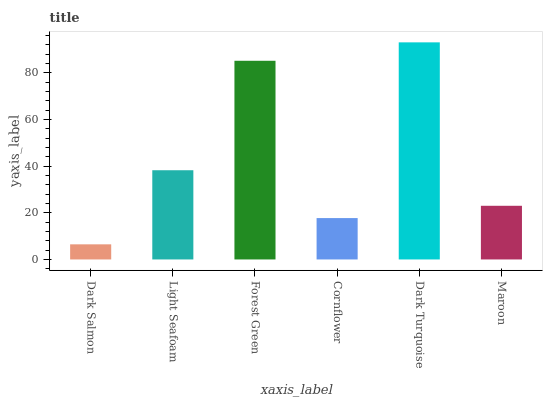Is Dark Salmon the minimum?
Answer yes or no. Yes. Is Dark Turquoise the maximum?
Answer yes or no. Yes. Is Light Seafoam the minimum?
Answer yes or no. No. Is Light Seafoam the maximum?
Answer yes or no. No. Is Light Seafoam greater than Dark Salmon?
Answer yes or no. Yes. Is Dark Salmon less than Light Seafoam?
Answer yes or no. Yes. Is Dark Salmon greater than Light Seafoam?
Answer yes or no. No. Is Light Seafoam less than Dark Salmon?
Answer yes or no. No. Is Light Seafoam the high median?
Answer yes or no. Yes. Is Maroon the low median?
Answer yes or no. Yes. Is Dark Salmon the high median?
Answer yes or no. No. Is Dark Turquoise the low median?
Answer yes or no. No. 